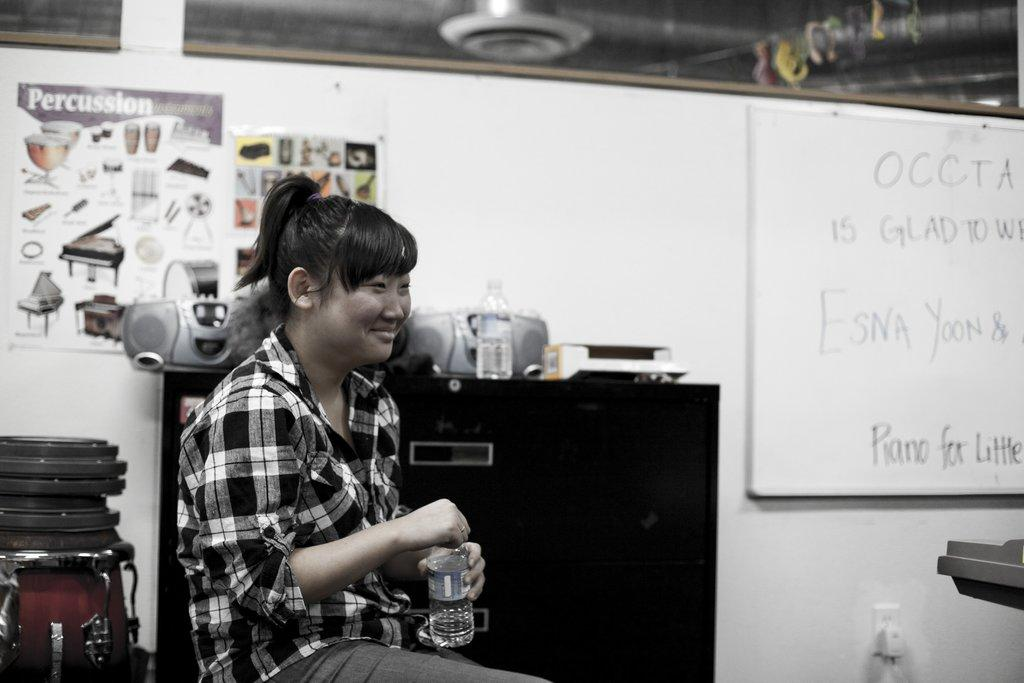<image>
Render a clear and concise summary of the photo. A woman smiling in front of a Percussion poster. 